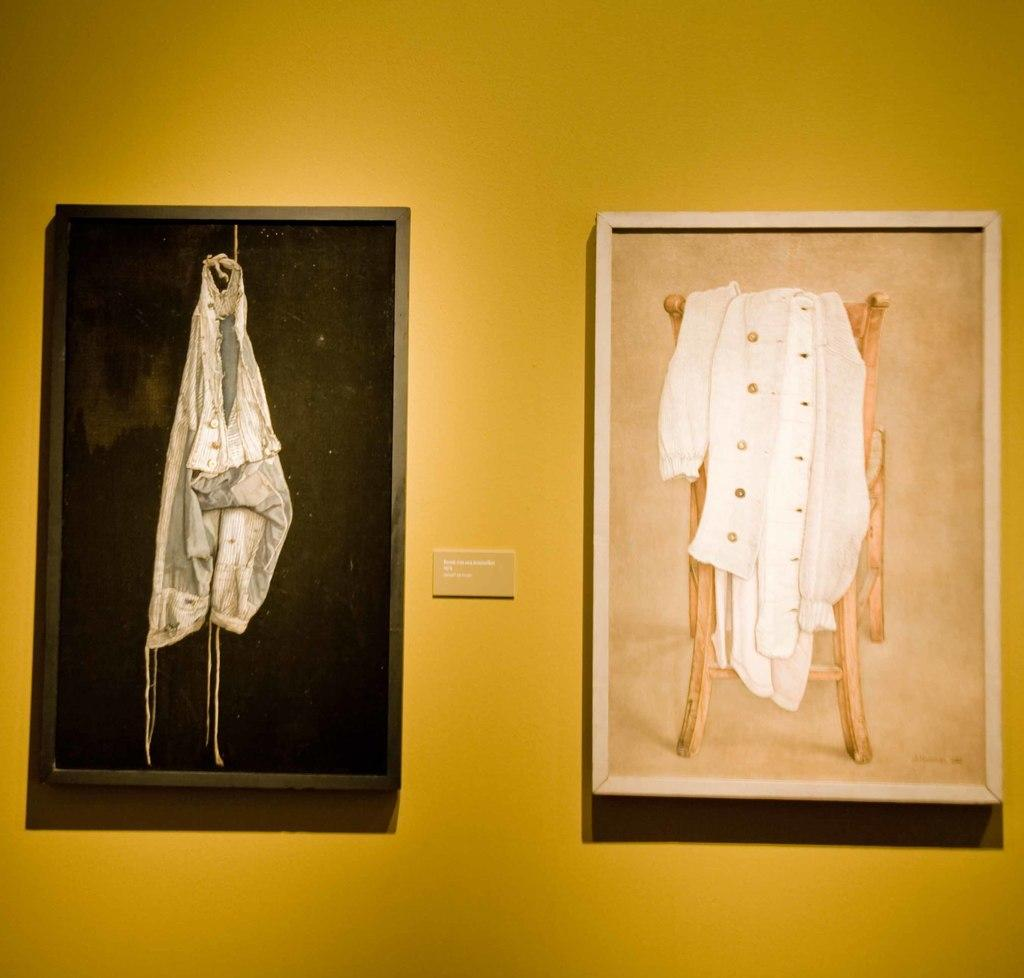What is hanging on the wall in the image? There are frames on the wall in the image. What colors are the frames? The frames are in black and cream color. What color is the wall? The wall is in yellow color. What type of carriage can be seen in the image? There is no carriage present in the image; it only features frames on the wall and a yellow wall. 